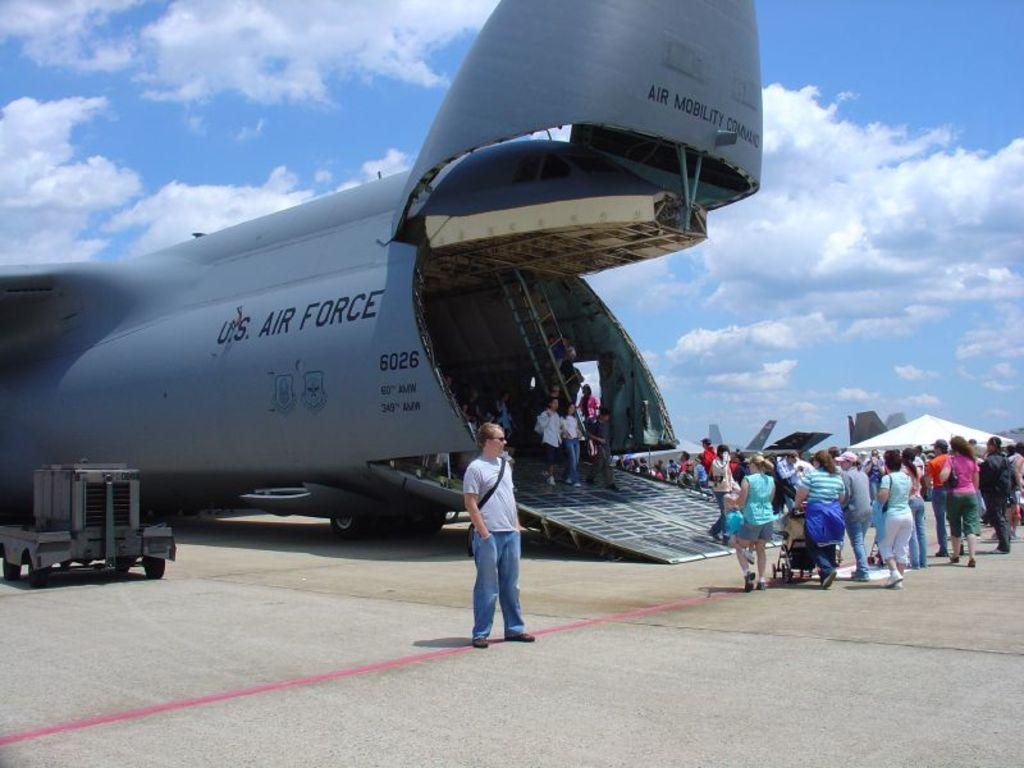<image>
Provide a brief description of the given image. People are surrounding a US Air Force plane. 